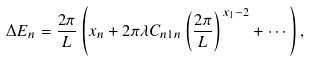Convert formula to latex. <formula><loc_0><loc_0><loc_500><loc_500>\Delta E _ { n } = \frac { 2 \pi } { L } \left ( x _ { n } + 2 \pi \lambda C _ { n 1 n } \left ( \frac { 2 \pi } { L } \right ) ^ { x _ { 1 } - 2 } + \cdots \right ) ,</formula> 